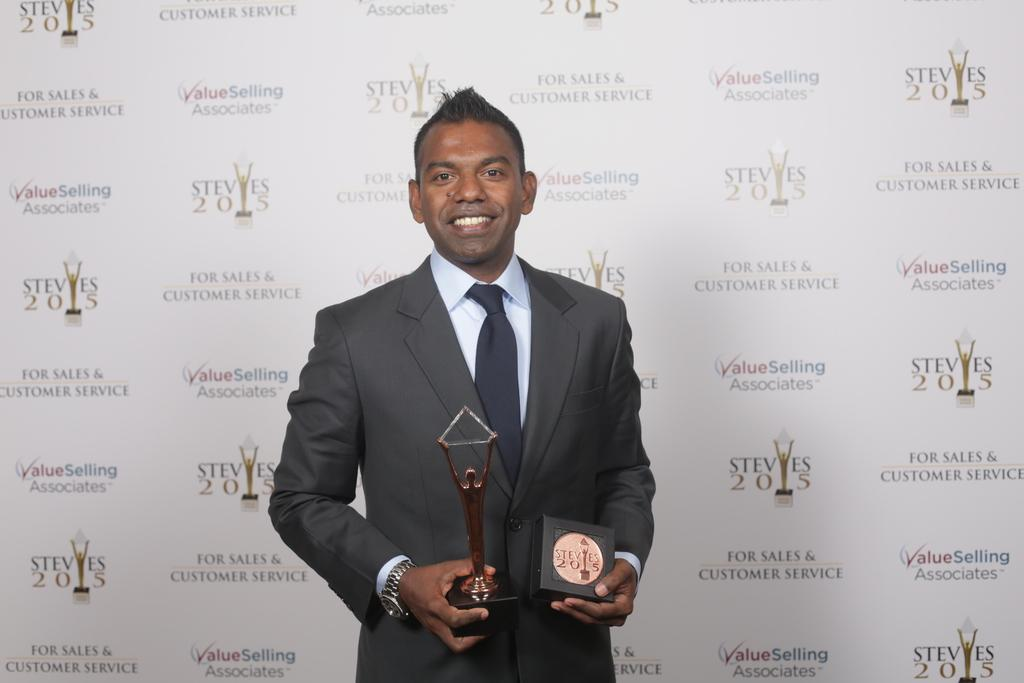What is the person in the image doing? The person is standing in the image. What is the person holding in the image? The person is holding a memento. What can be seen in the background of the image? There is a board visible in the background of the image. What is the person's tendency to make errors in the image? There is no indication in the image of the person's tendency to make errors. What type of loaf is present on the board in the background? There is no loaf present on the board in the background; it is a board with no visible loaf. 